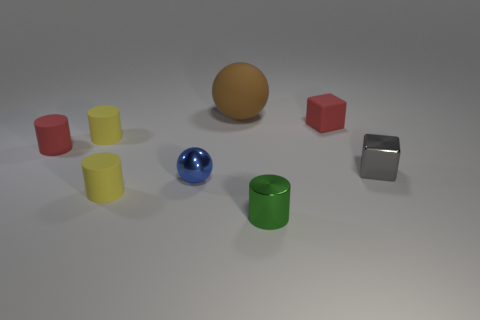What size is the red rubber thing that is the same shape as the tiny green object?
Offer a very short reply. Small. What color is the other small thing that is the same shape as the small gray object?
Keep it short and to the point. Red. There is a small matte thing that is the same color as the rubber block; what shape is it?
Provide a short and direct response. Cylinder. What number of objects are either spheres that are in front of the brown matte sphere or tiny red things that are on the left side of the blue metal sphere?
Your answer should be very brief. 2. There is a cube behind the small block that is in front of the tiny rubber object that is to the right of the large matte sphere; what is its color?
Make the answer very short. Red. Are there any large red objects of the same shape as the tiny gray shiny thing?
Keep it short and to the point. No. What number of cyan spheres are there?
Your answer should be very brief. 0. There is a small blue object; what shape is it?
Make the answer very short. Sphere. What number of matte things have the same size as the gray cube?
Provide a succinct answer. 4. Do the big matte object and the small blue object have the same shape?
Ensure brevity in your answer.  Yes. 